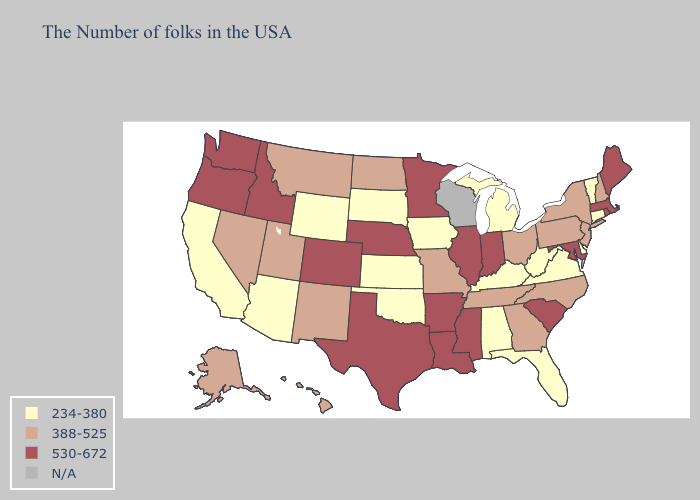Among the states that border Kentucky , does Virginia have the highest value?
Concise answer only. No. Name the states that have a value in the range 530-672?
Keep it brief. Maine, Massachusetts, Rhode Island, Maryland, South Carolina, Indiana, Illinois, Mississippi, Louisiana, Arkansas, Minnesota, Nebraska, Texas, Colorado, Idaho, Washington, Oregon. What is the highest value in the West ?
Be succinct. 530-672. What is the value of New Mexico?
Quick response, please. 388-525. Is the legend a continuous bar?
Quick response, please. No. Name the states that have a value in the range 234-380?
Concise answer only. Vermont, Connecticut, Delaware, Virginia, West Virginia, Florida, Michigan, Kentucky, Alabama, Iowa, Kansas, Oklahoma, South Dakota, Wyoming, Arizona, California. What is the value of North Carolina?
Keep it brief. 388-525. What is the value of Georgia?
Give a very brief answer. 388-525. Name the states that have a value in the range 234-380?
Give a very brief answer. Vermont, Connecticut, Delaware, Virginia, West Virginia, Florida, Michigan, Kentucky, Alabama, Iowa, Kansas, Oklahoma, South Dakota, Wyoming, Arizona, California. Does Connecticut have the lowest value in the Northeast?
Keep it brief. Yes. What is the value of Ohio?
Keep it brief. 388-525. What is the lowest value in the South?
Answer briefly. 234-380. Which states have the lowest value in the West?
Give a very brief answer. Wyoming, Arizona, California. 